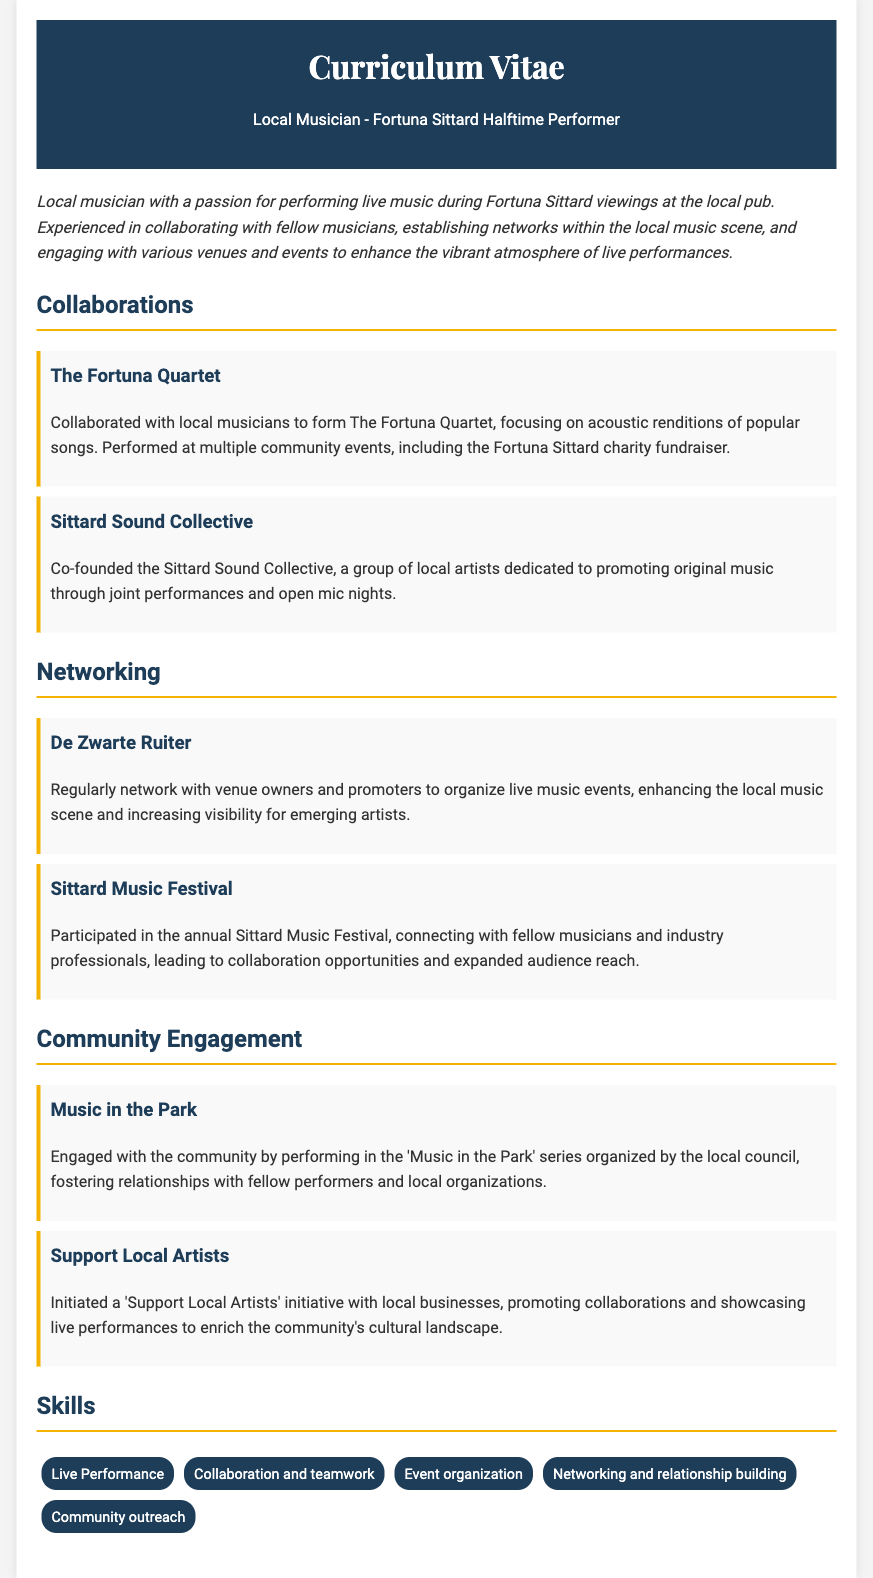What is the name of the collaboration that focuses on acoustic renditions? The collaboration that focuses on acoustic renditions is called The Fortuna Quartet.
Answer: The Fortuna Quartet Who co-founded the Sittard Sound Collective? The Sittard Sound Collective was co-founded by the local musician.
Answer: local musician Which venue is mentioned for networking with owners and promoters? The venue mentioned for networking is De Zwarte Ruiter.
Answer: De Zwarte Ruiter What annual event did the musician participate in to connect with others? The musician participated in the Sittard Music Festival to connect with others.
Answer: Sittard Music Festival What community engagement series involves performing in the park? The community engagement series that involves performing in the park is called 'Music in the Park'.
Answer: Music in the Park What initiative promotes collaborations with local businesses? The initiative that promotes collaborations with local businesses is titled 'Support Local Artists'.
Answer: Support Local Artists How many collaborations are listed in the document? There are two collaborations listed in the document.
Answer: two Which skill involves enhancing the cultural landscape of the community? The skill that involves enhancing the cultural landscape of the community is community outreach.
Answer: community outreach 